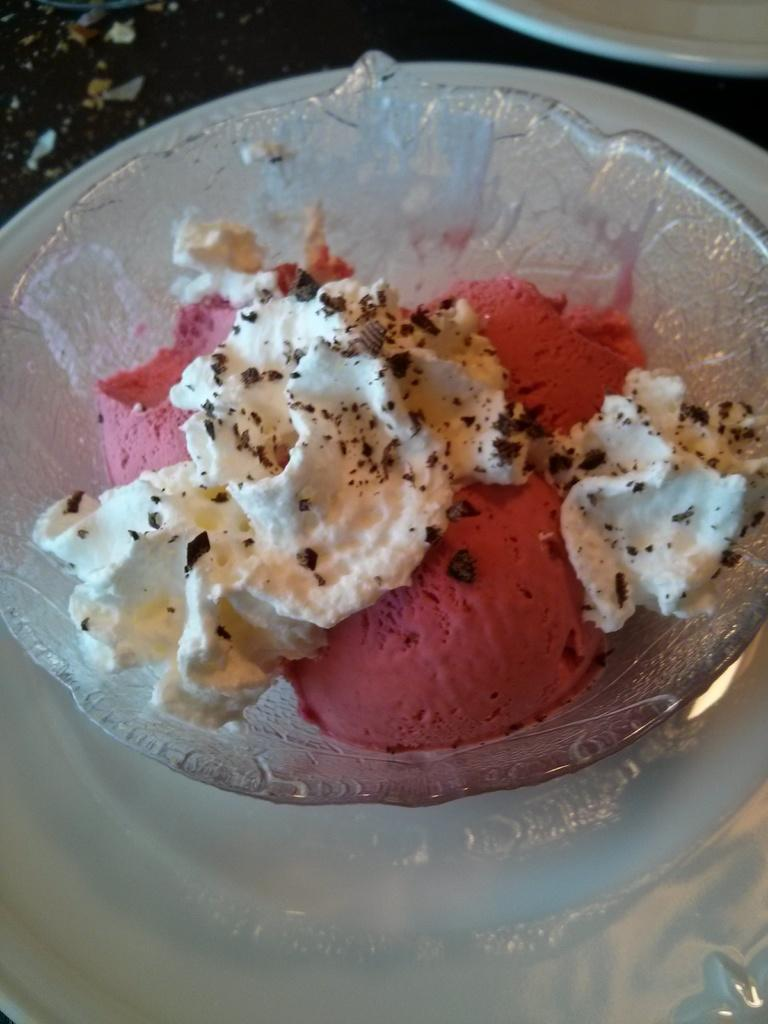What is in the bowl that is visible in the image? There is a bowl with ice cream in the image. What is the bowl placed on? The bowl is on a white plate. Can you describe the background of the image? There is an object in the background of the image. What type of waves can be seen crashing on the shore in the image? There are no waves or shore visible in the image; it features a bowl of ice cream on a white plate with an object in the background. 